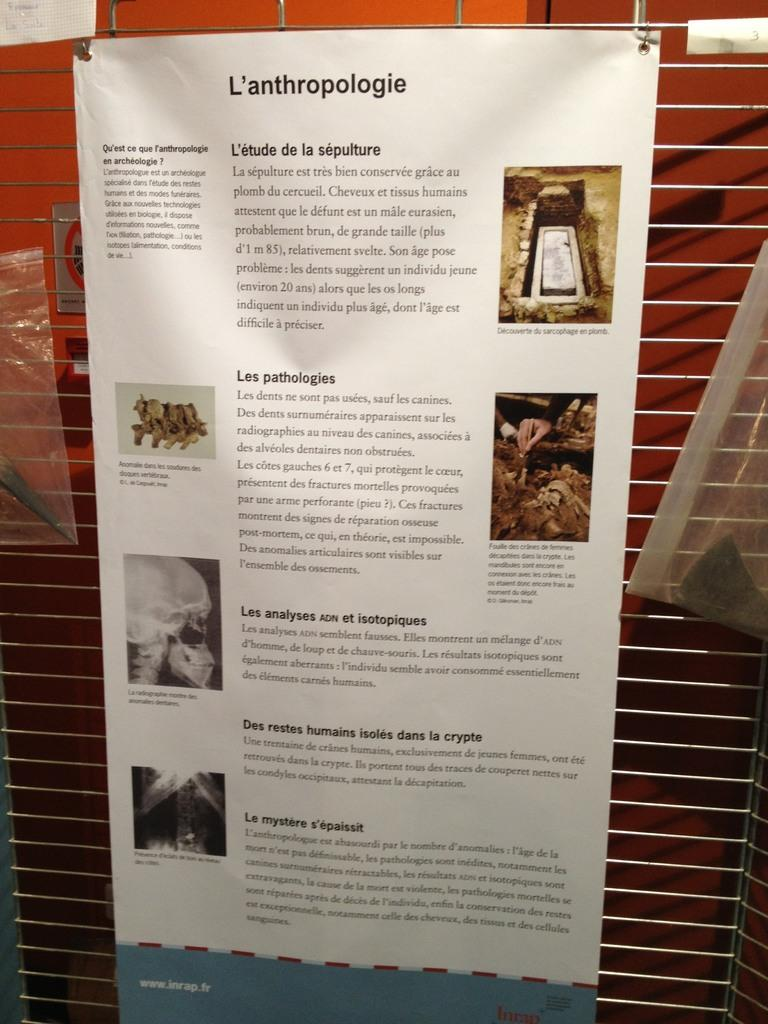<image>
Share a concise interpretation of the image provided. A informational poster titled L'anthropologie is hanging from a metal gate. 